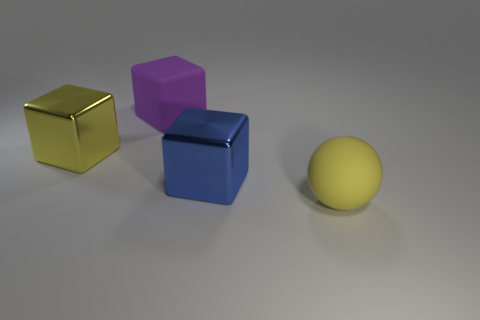There is a block that is the same color as the rubber ball; what is its size?
Your answer should be very brief. Large. Are there any blue things of the same size as the blue block?
Your response must be concise. No. Is the big purple block made of the same material as the large yellow thing that is left of the big yellow matte sphere?
Provide a short and direct response. No. Are there more tiny red matte objects than big blue shiny objects?
Your response must be concise. No. How many cylinders are either yellow things or large purple objects?
Your answer should be very brief. 0. What color is the big rubber ball?
Provide a short and direct response. Yellow. There is a yellow object that is in front of the big yellow shiny object; is it the same size as the shiny object left of the large purple matte block?
Your answer should be compact. Yes. Are there fewer large metal cubes than rubber spheres?
Keep it short and to the point. No. There is a large matte sphere; how many purple rubber blocks are behind it?
Give a very brief answer. 1. What is the material of the purple thing?
Make the answer very short. Rubber. 